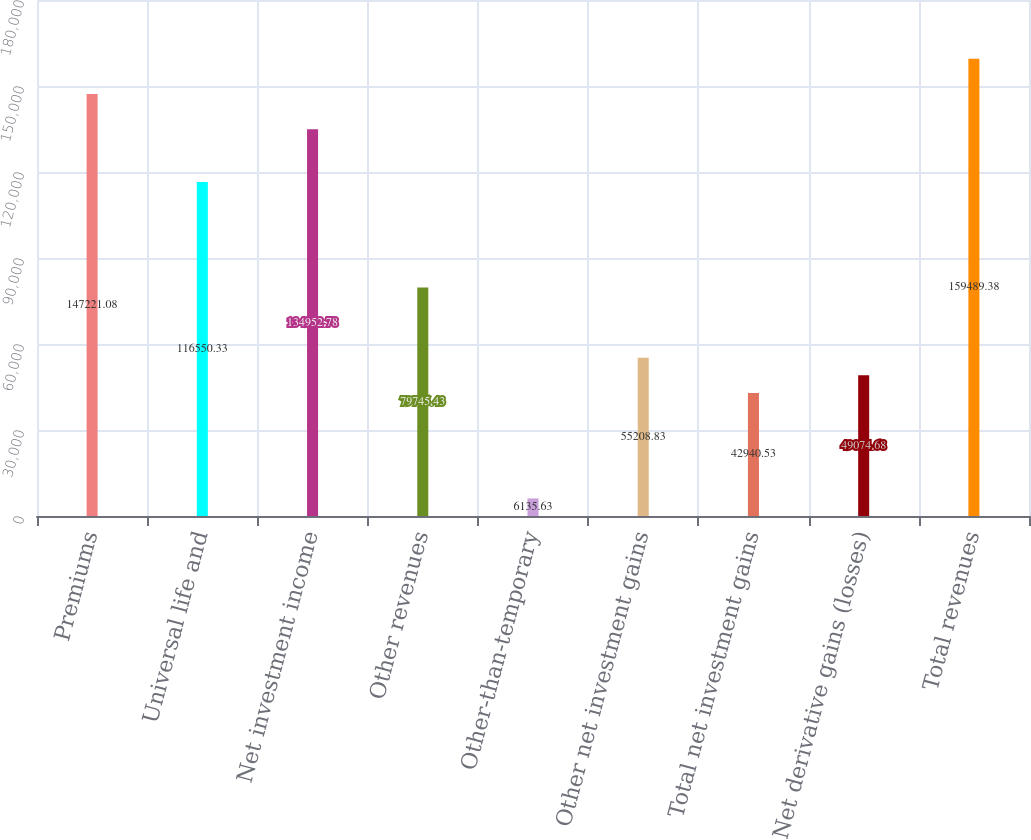<chart> <loc_0><loc_0><loc_500><loc_500><bar_chart><fcel>Premiums<fcel>Universal life and<fcel>Net investment income<fcel>Other revenues<fcel>Other-than-temporary<fcel>Other net investment gains<fcel>Total net investment gains<fcel>Net derivative gains (losses)<fcel>Total revenues<nl><fcel>147221<fcel>116550<fcel>134953<fcel>79745.4<fcel>6135.63<fcel>55208.8<fcel>42940.5<fcel>49074.7<fcel>159489<nl></chart> 